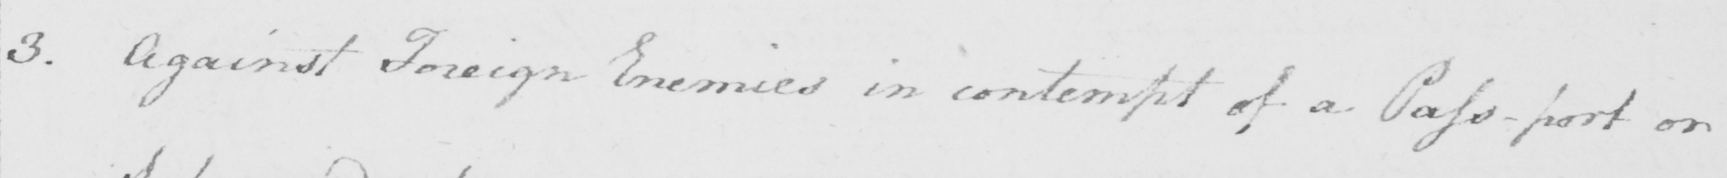What text is written in this handwritten line? 3 . Against Foreign Enemies in contempt of a Pass-port on 